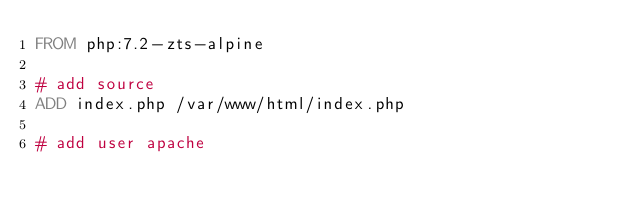Convert code to text. <code><loc_0><loc_0><loc_500><loc_500><_Dockerfile_>FROM php:7.2-zts-alpine

# add source
ADD index.php /var/www/html/index.php

# add user apache</code> 